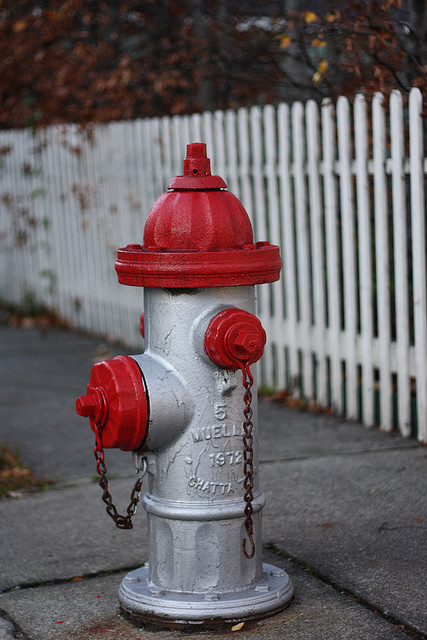Please transcribe the text in this image. 1972 CHATTR 